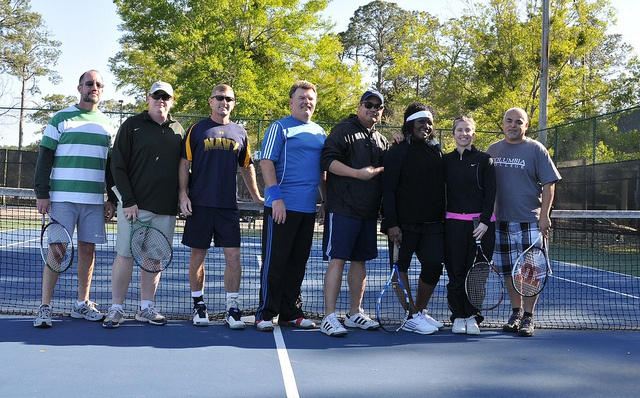Describe the objects in this image and their specific colors. I can see people in lightgray, teal, gray, and black tones, people in lightgray, black, gray, and darkgray tones, people in lightgray, black, blue, navy, and gray tones, people in lightgray, black, gray, and darkgray tones, and people in lightgray, black, gray, and darkgray tones in this image. 